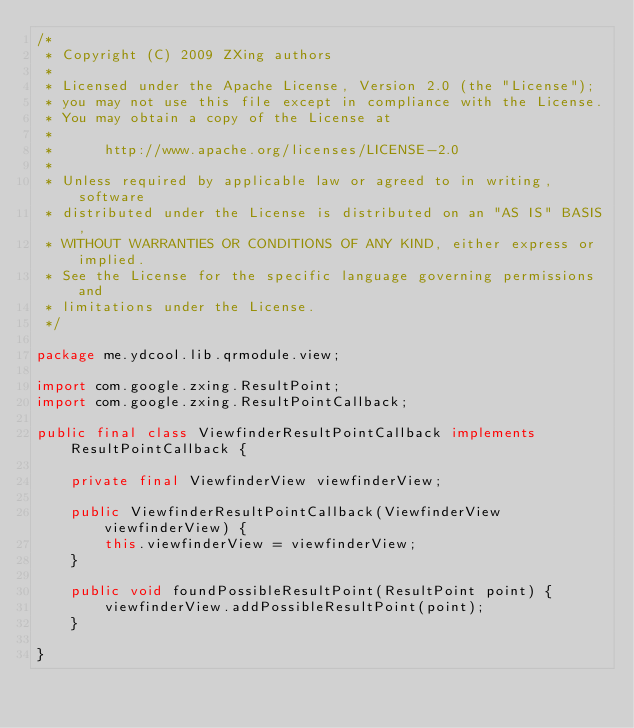<code> <loc_0><loc_0><loc_500><loc_500><_Java_>/*
 * Copyright (C) 2009 ZXing authors
 *
 * Licensed under the Apache License, Version 2.0 (the "License");
 * you may not use this file except in compliance with the License.
 * You may obtain a copy of the License at
 *
 *      http://www.apache.org/licenses/LICENSE-2.0
 *
 * Unless required by applicable law or agreed to in writing, software
 * distributed under the License is distributed on an "AS IS" BASIS,
 * WITHOUT WARRANTIES OR CONDITIONS OF ANY KIND, either express or implied.
 * See the License for the specific language governing permissions and
 * limitations under the License.
 */

package me.ydcool.lib.qrmodule.view;

import com.google.zxing.ResultPoint;
import com.google.zxing.ResultPointCallback;

public final class ViewfinderResultPointCallback implements ResultPointCallback {

    private final ViewfinderView viewfinderView;

    public ViewfinderResultPointCallback(ViewfinderView viewfinderView) {
        this.viewfinderView = viewfinderView;
    }

    public void foundPossibleResultPoint(ResultPoint point) {
        viewfinderView.addPossibleResultPoint(point);
    }

}
</code> 